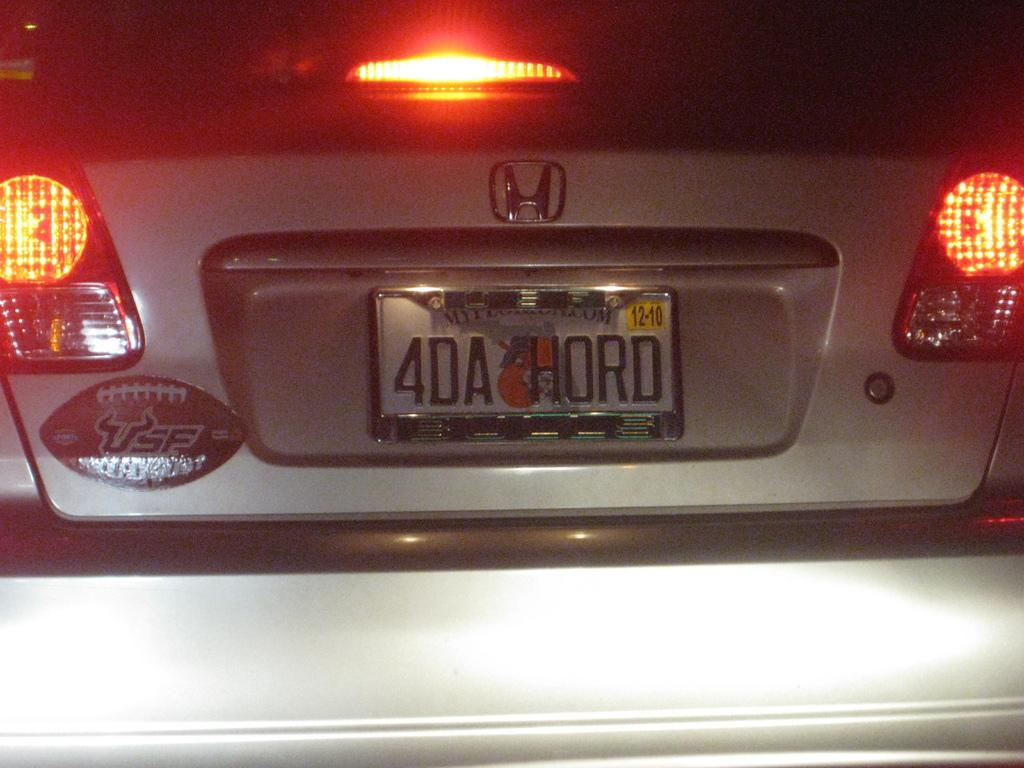<image>
Create a compact narrative representing the image presented. A silver Honda with a Florida tag reading 4DA HORD. 